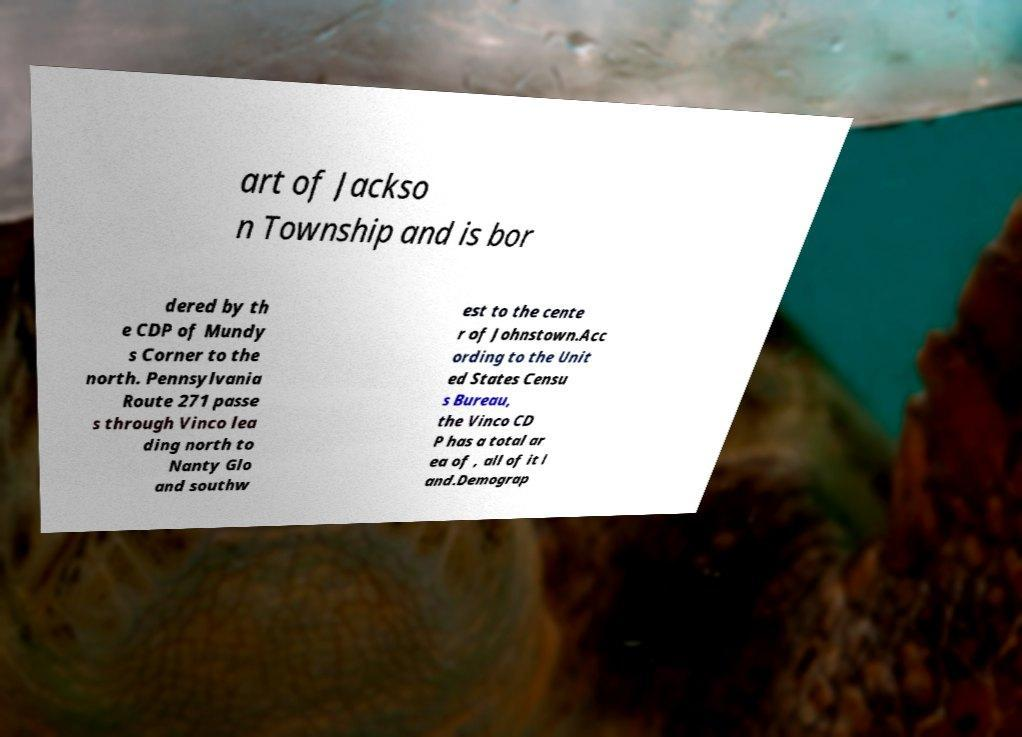Please identify and transcribe the text found in this image. art of Jackso n Township and is bor dered by th e CDP of Mundy s Corner to the north. Pennsylvania Route 271 passe s through Vinco lea ding north to Nanty Glo and southw est to the cente r of Johnstown.Acc ording to the Unit ed States Censu s Bureau, the Vinco CD P has a total ar ea of , all of it l and.Demograp 